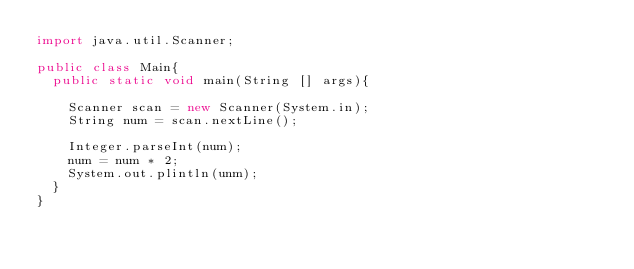<code> <loc_0><loc_0><loc_500><loc_500><_Java_>import java.util.Scanner;

public class Main{
  public static void main(String [] args){
    
    Scanner scan = new Scanner(System.in);
    String num = scan.nextLine();
    
    Integer.parseInt(num);
    num = num * 2;
    System.out.plintln(unm);
  }
}

    </code> 